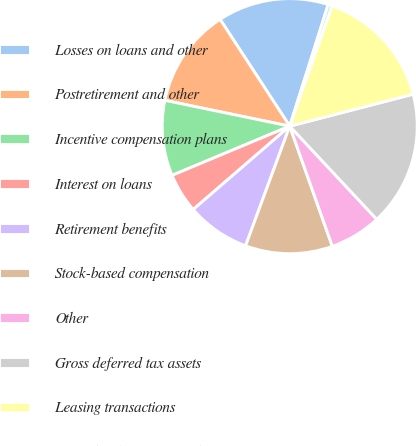<chart> <loc_0><loc_0><loc_500><loc_500><pie_chart><fcel>Losses on loans and other<fcel>Postretirement and other<fcel>Incentive compensation plans<fcel>Interest on loans<fcel>Retirement benefits<fcel>Stock-based compensation<fcel>Other<fcel>Gross deferred tax assets<fcel>Leasing transactions<fcel>Capitalized servicing rights<nl><fcel>14.07%<fcel>12.56%<fcel>9.55%<fcel>5.03%<fcel>8.04%<fcel>11.05%<fcel>6.53%<fcel>17.08%<fcel>15.58%<fcel>0.51%<nl></chart> 